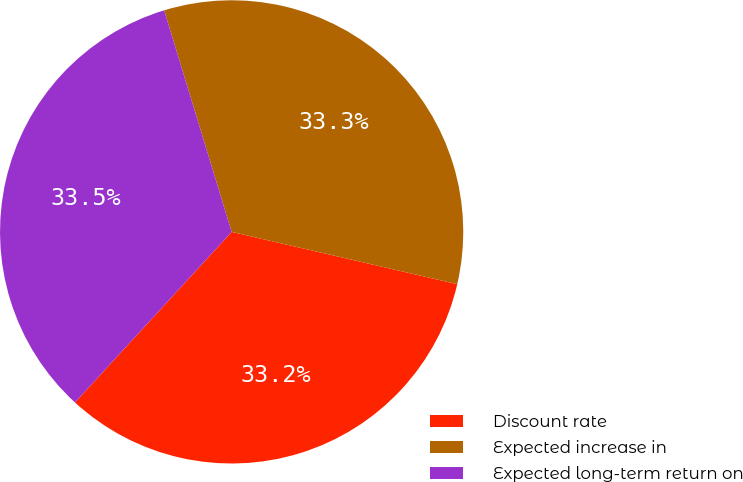<chart> <loc_0><loc_0><loc_500><loc_500><pie_chart><fcel>Discount rate<fcel>Expected increase in<fcel>Expected long-term return on<nl><fcel>33.2%<fcel>33.33%<fcel>33.47%<nl></chart> 